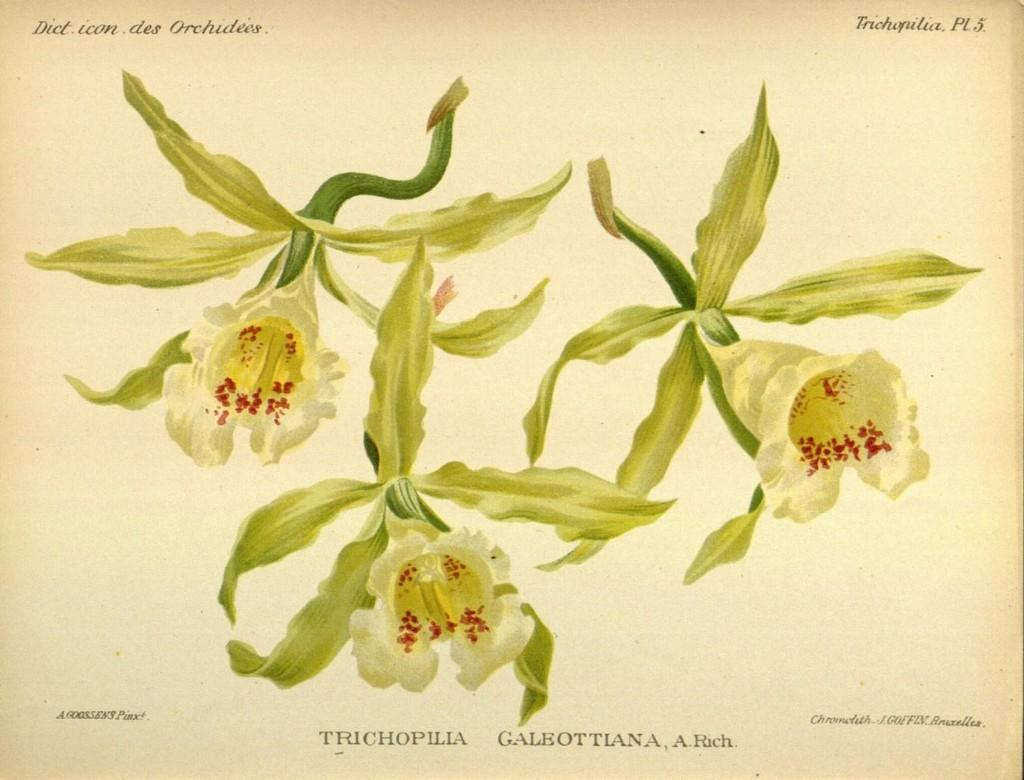What is the medium of the image? The image might be a painting on paper. What type of plant is depicted in the image? There is a flower in the image. What other part of the plant can be seen in the image? There are green leaves in the image. What is the scent of the flower in the image? The image is not a real flower, so it does not have a scent. 